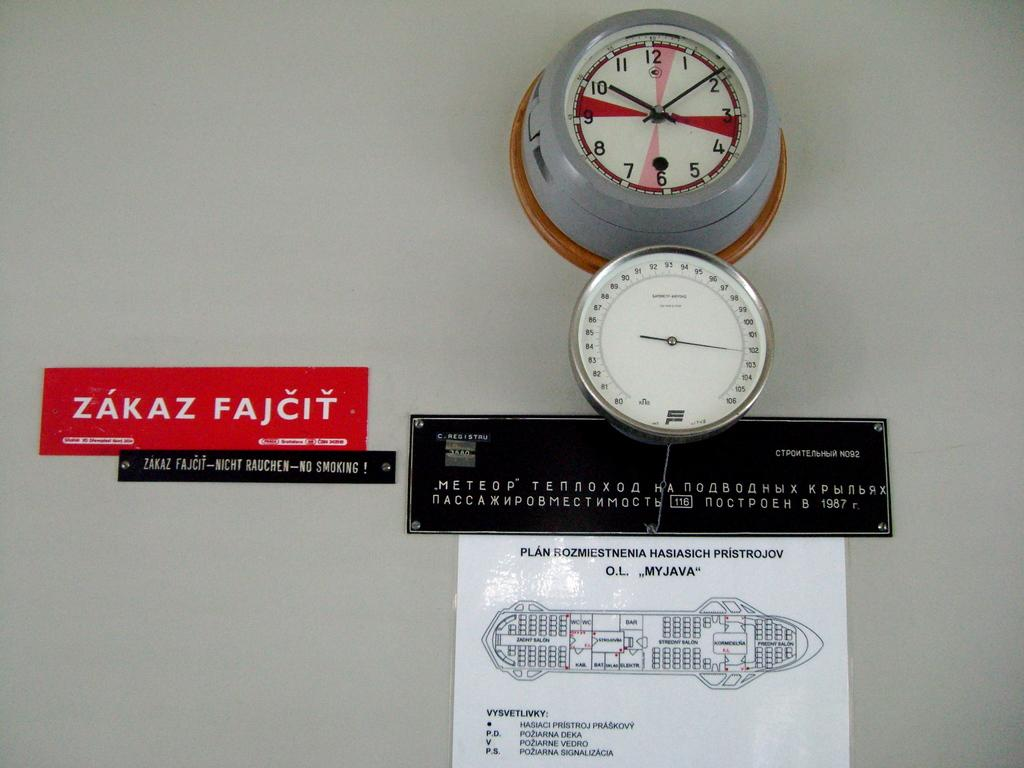<image>
Relay a brief, clear account of the picture shown. A wall with multiple signs and a clock, one of which says Zakaz Fajcit. 